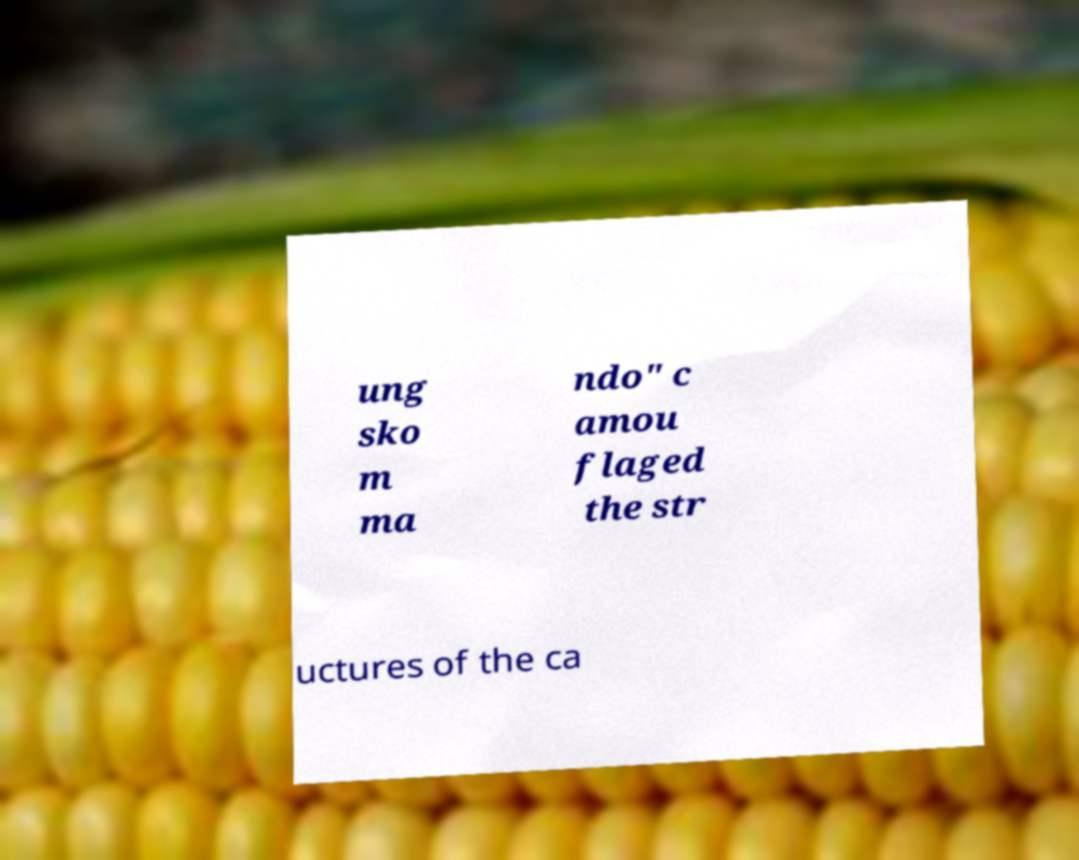Please read and relay the text visible in this image. What does it say? ung sko m ma ndo" c amou flaged the str uctures of the ca 